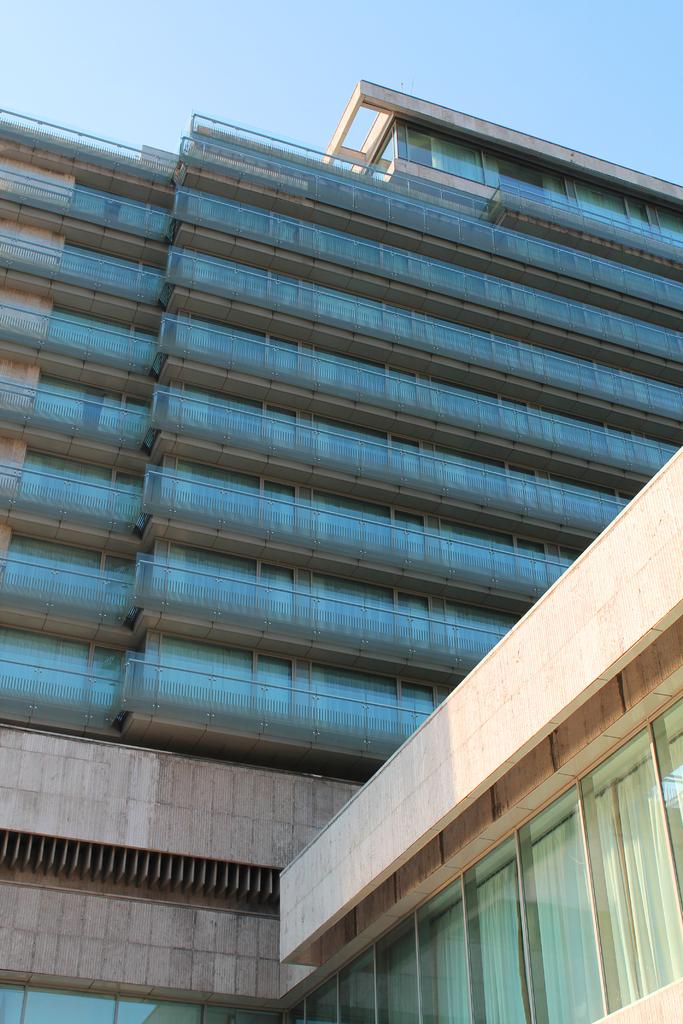What is the main subject of the image? The main subject of the image is a building. What specific features can be observed on the building? The building has windows. What can be seen in the background of the image? The sky is visible in the background of the image. What type of jar is visible on the roof of the building in the image? There is no jar visible on the roof of the building in the image. What disease can be seen affecting the building in the image? There is no disease present in the image; it features a building with windows and a visible sky in the background. 